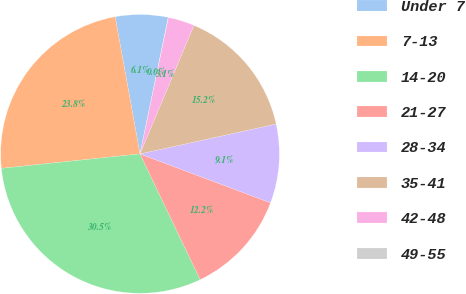Convert chart. <chart><loc_0><loc_0><loc_500><loc_500><pie_chart><fcel>Under 7<fcel>7-13<fcel>14-20<fcel>21-27<fcel>28-34<fcel>35-41<fcel>42-48<fcel>49-55<nl><fcel>6.1%<fcel>23.8%<fcel>30.45%<fcel>12.19%<fcel>9.15%<fcel>15.23%<fcel>3.06%<fcel>0.02%<nl></chart> 